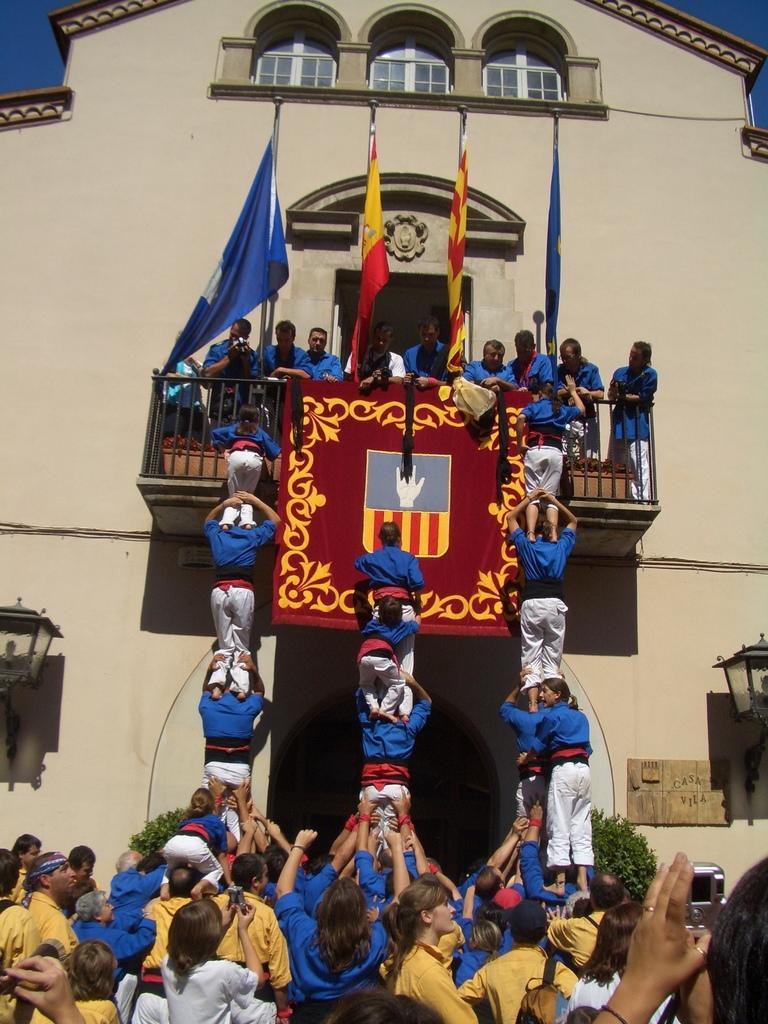In one or two sentences, can you explain what this image depicts? In front of the image there are a few people standing. In front of them there are human pyramids. In front of them there is a building with a few people on the balcony with metal rod fence, on the balcony there is a banner and there are flags. In the building there are lamps and glass windows. At the top of the image there is sky. 